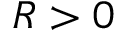<formula> <loc_0><loc_0><loc_500><loc_500>R > 0</formula> 